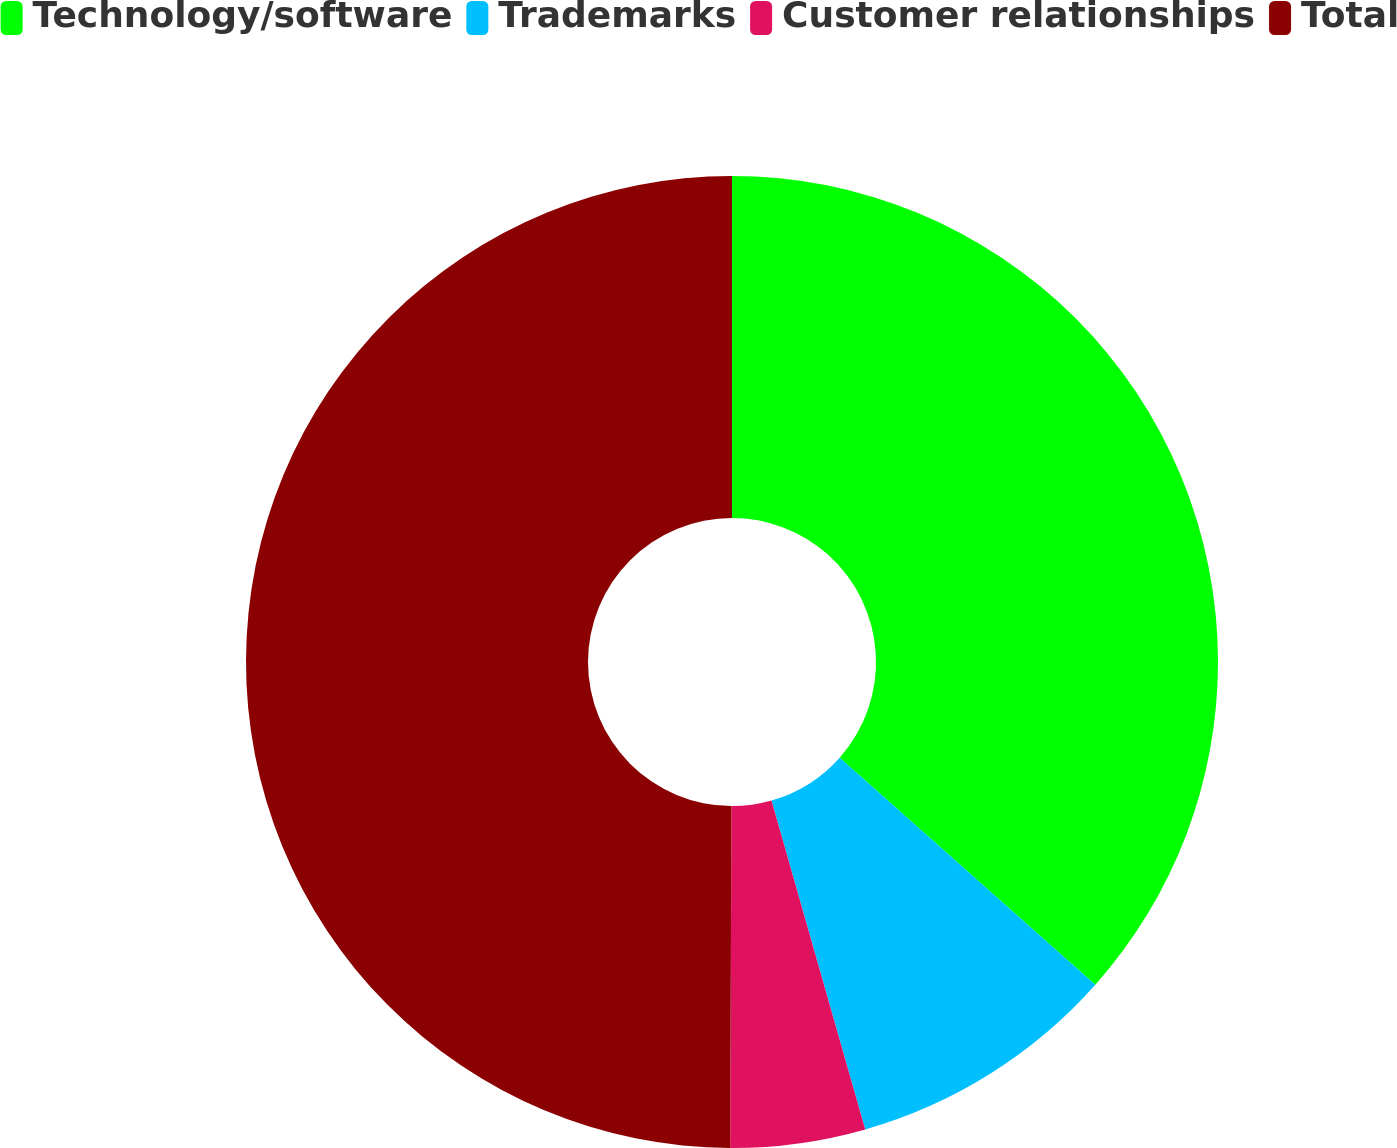Convert chart. <chart><loc_0><loc_0><loc_500><loc_500><pie_chart><fcel>Technology/software<fcel>Trademarks<fcel>Customer relationships<fcel>Total<nl><fcel>36.56%<fcel>9.02%<fcel>4.48%<fcel>49.94%<nl></chart> 